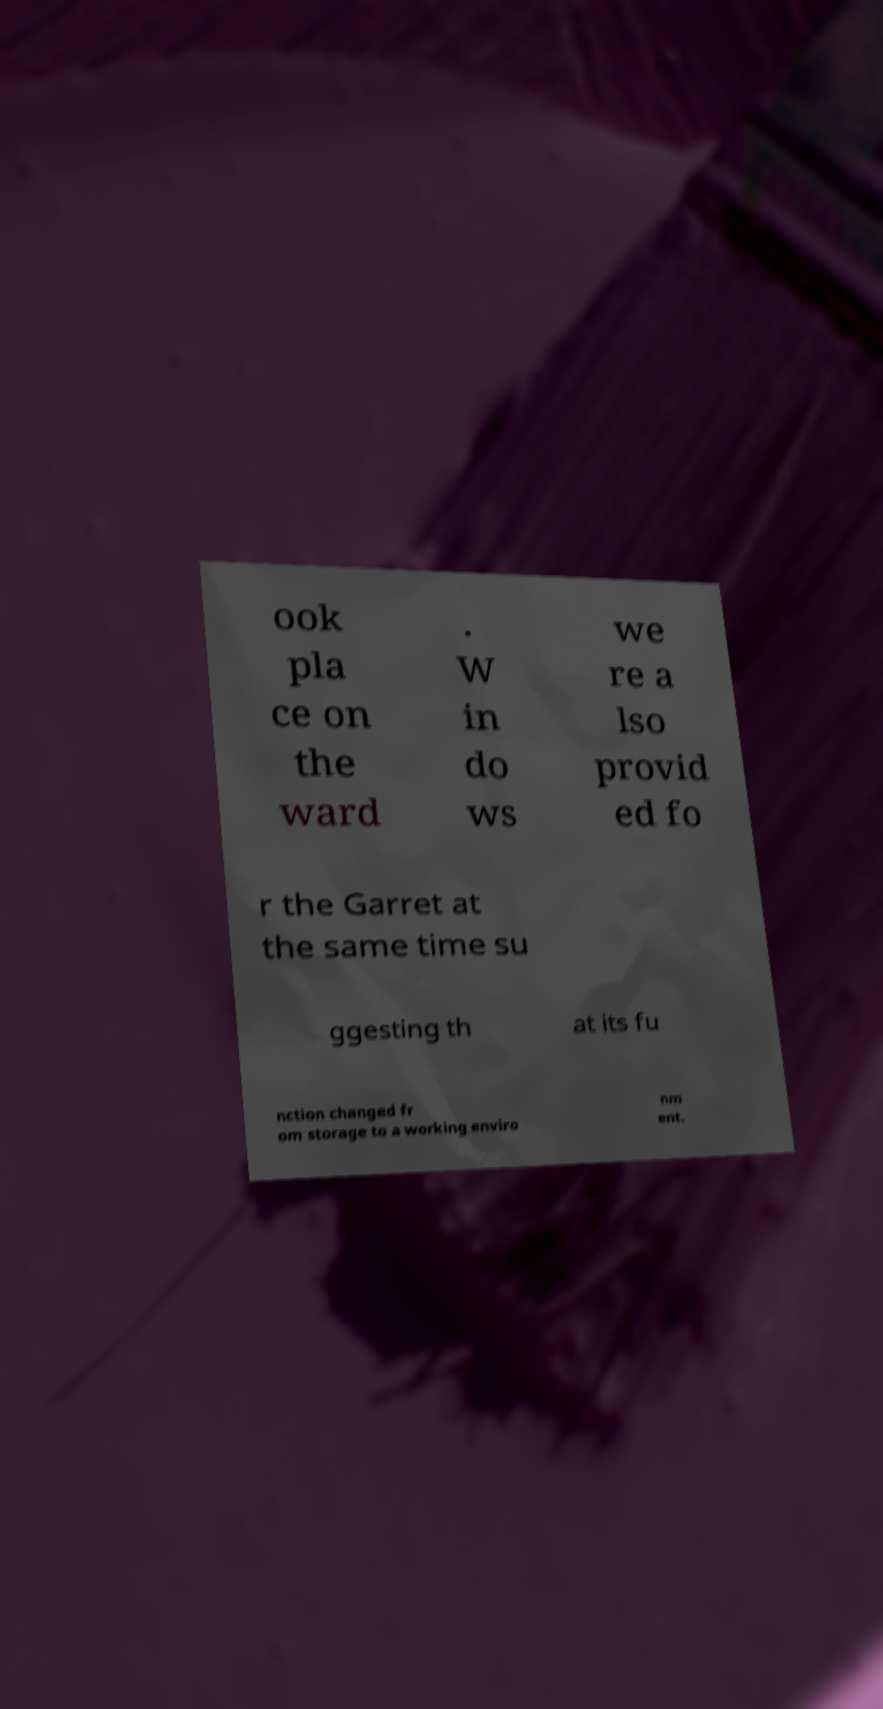Can you accurately transcribe the text from the provided image for me? ook pla ce on the ward . W in do ws we re a lso provid ed fo r the Garret at the same time su ggesting th at its fu nction changed fr om storage to a working enviro nm ent. 